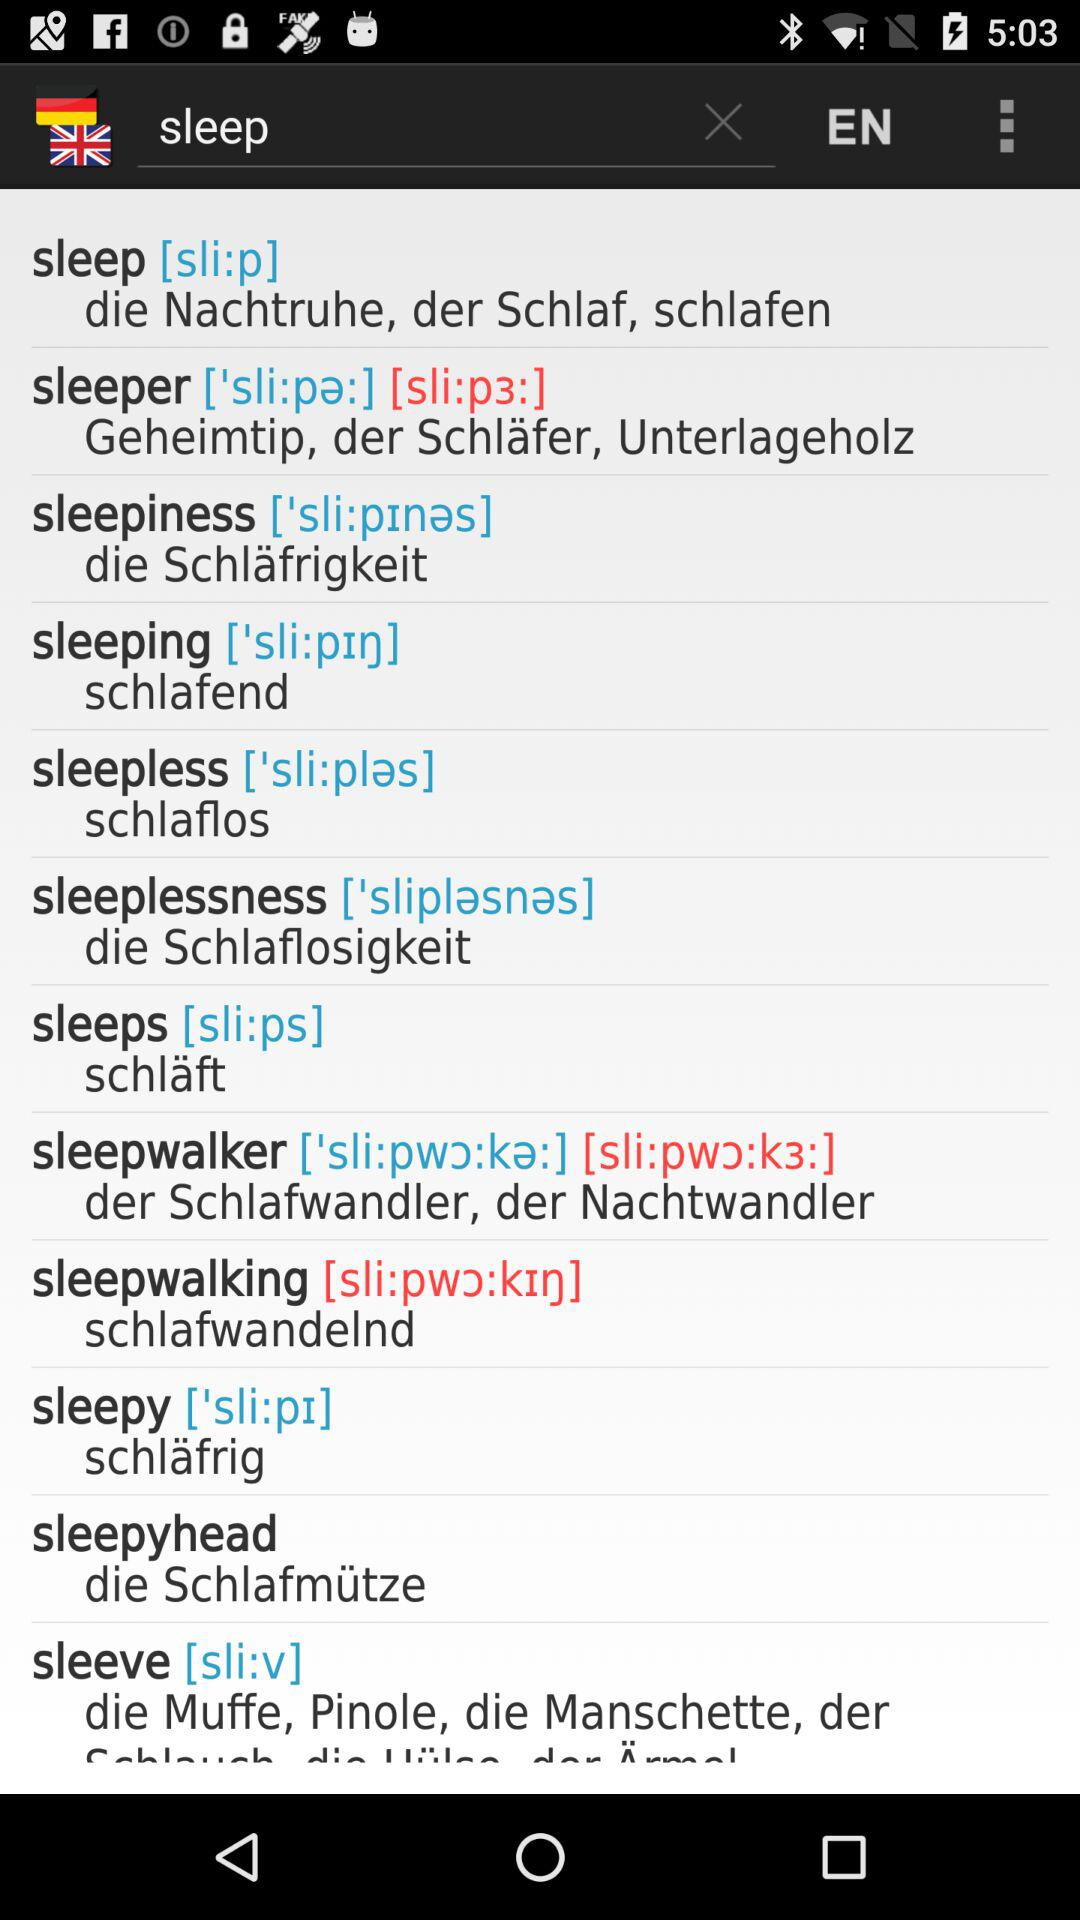What is the input text entered in the text bar? The entered input text is "sleep". 